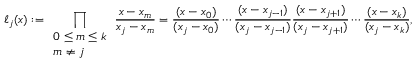Convert formula to latex. <formula><loc_0><loc_0><loc_500><loc_500>\ell _ { j } ( x ) \colon = \prod _ { \begin{array} { l } { 0 \leq m \leq k } \\ { m \neq j } \end{array} } { \frac { x - x _ { m } } { x _ { j } - x _ { m } } } = { \frac { ( x - x _ { 0 } ) } { ( x _ { j } - x _ { 0 } ) } } \cdots { \frac { ( x - x _ { j - 1 } ) } { ( x _ { j } - x _ { j - 1 } ) } } { \frac { ( x - x _ { j + 1 } ) } { ( x _ { j } - x _ { j + 1 } ) } } \cdots { \frac { ( x - x _ { k } ) } { ( x _ { j } - x _ { k } ) } } ,</formula> 